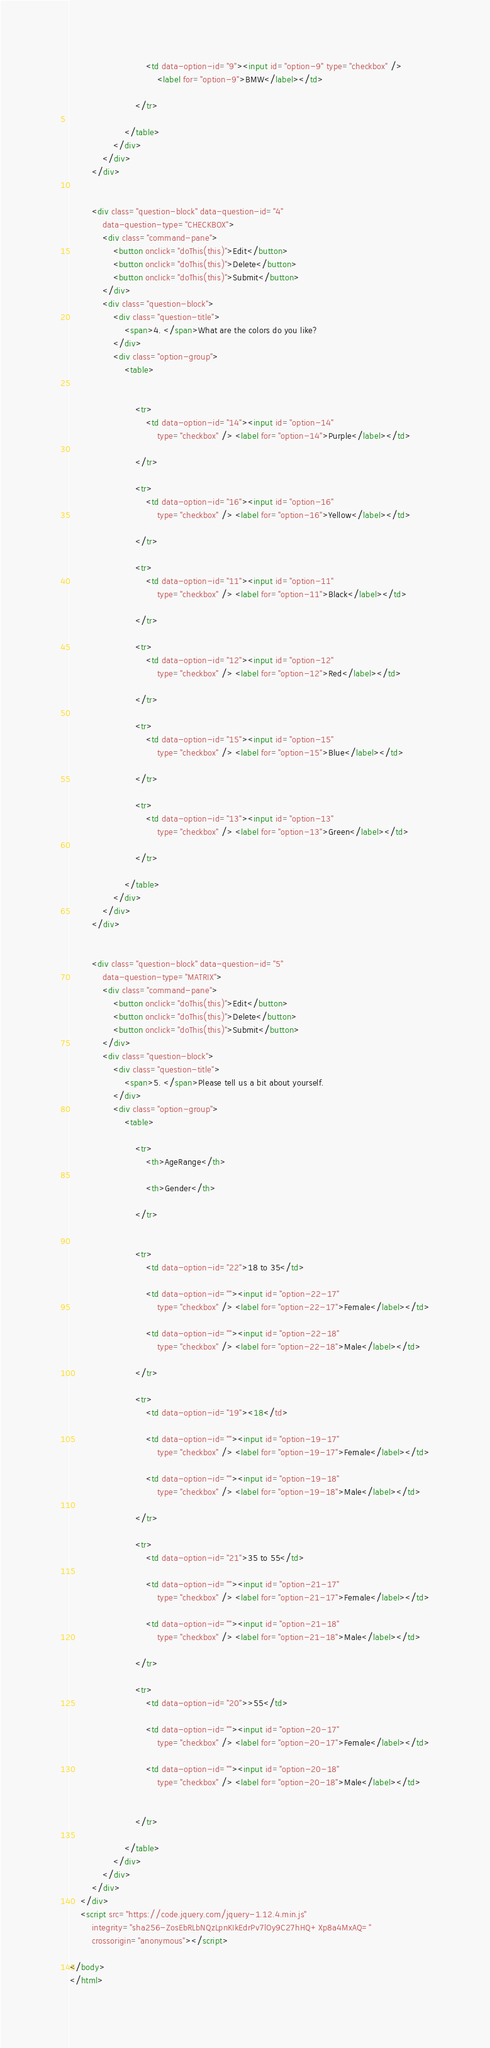<code> <loc_0><loc_0><loc_500><loc_500><_HTML_>							<td data-option-id="9"><input id="option-9" type="checkbox" />
								<label for="option-9">BMW</label></td>

						</tr>

					</table>
				</div>
			</div>
		</div>


		<div class="question-block" data-question-id="4"
			data-question-type="CHECKBOX">
			<div class="command-pane">
				<button onclick="doThis(this)">Edit</button>
				<button onclick="doThis(this)">Delete</button>
				<button onclick="doThis(this)">Submit</button>
			</div>
			<div class="question-block">
				<div class="question-title">
					<span>4. </span>What are the colors do you like?
				</div>
				<div class="option-group">
					<table>


						<tr>
							<td data-option-id="14"><input id="option-14"
								type="checkbox" /> <label for="option-14">Purple</label></td>

						</tr>

						<tr>
							<td data-option-id="16"><input id="option-16"
								type="checkbox" /> <label for="option-16">Yellow</label></td>

						</tr>

						<tr>
							<td data-option-id="11"><input id="option-11"
								type="checkbox" /> <label for="option-11">Black</label></td>

						</tr>

						<tr>
							<td data-option-id="12"><input id="option-12"
								type="checkbox" /> <label for="option-12">Red</label></td>

						</tr>

						<tr>
							<td data-option-id="15"><input id="option-15"
								type="checkbox" /> <label for="option-15">Blue</label></td>

						</tr>

						<tr>
							<td data-option-id="13"><input id="option-13"
								type="checkbox" /> <label for="option-13">Green</label></td>

						</tr>

					</table>
				</div>
			</div>
		</div>


		<div class="question-block" data-question-id="5"
			data-question-type="MATRIX">
			<div class="command-pane">
				<button onclick="doThis(this)">Edit</button>
				<button onclick="doThis(this)">Delete</button>
				<button onclick="doThis(this)">Submit</button>
			</div>
			<div class="question-block">
				<div class="question-title">
					<span>5. </span>Please tell us a bit about yourself.
				</div>
				<div class="option-group">
					<table>

						<tr>
							<th>AgeRange</th>

							<th>Gender</th>

						</tr>


						<tr>
							<td data-option-id="22">18 to 35</td>

							<td data-option-id=""><input id="option-22-17"
								type="checkbox" /> <label for="option-22-17">Female</label></td>

							<td data-option-id=""><input id="option-22-18"
								type="checkbox" /> <label for="option-22-18">Male</label></td>

						</tr>

						<tr>
							<td data-option-id="19"><18</td>

							<td data-option-id=""><input id="option-19-17"
								type="checkbox" /> <label for="option-19-17">Female</label></td>

							<td data-option-id=""><input id="option-19-18"
								type="checkbox" /> <label for="option-19-18">Male</label></td>

						</tr>

						<tr>
							<td data-option-id="21">35 to 55</td>

							<td data-option-id=""><input id="option-21-17"
								type="checkbox" /> <label for="option-21-17">Female</label></td>

							<td data-option-id=""><input id="option-21-18"
								type="checkbox" /> <label for="option-21-18">Male</label></td>

						</tr>

						<tr>
							<td data-option-id="20">>55</td>

							<td data-option-id=""><input id="option-20-17"
								type="checkbox" /> <label for="option-20-17">Female</label></td>

							<td data-option-id=""><input id="option-20-18"
								type="checkbox" /> <label for="option-20-18">Male</label></td>


						</tr>

					</table>
				</div>
			</div>
		</div>
	</div>
	<script src="https://code.jquery.com/jquery-1.12.4.min.js"
		integrity="sha256-ZosEbRLbNQzLpnKIkEdrPv7lOy9C27hHQ+Xp8a4MxAQ="
		crossorigin="anonymous"></script>

</body>
</html></code> 